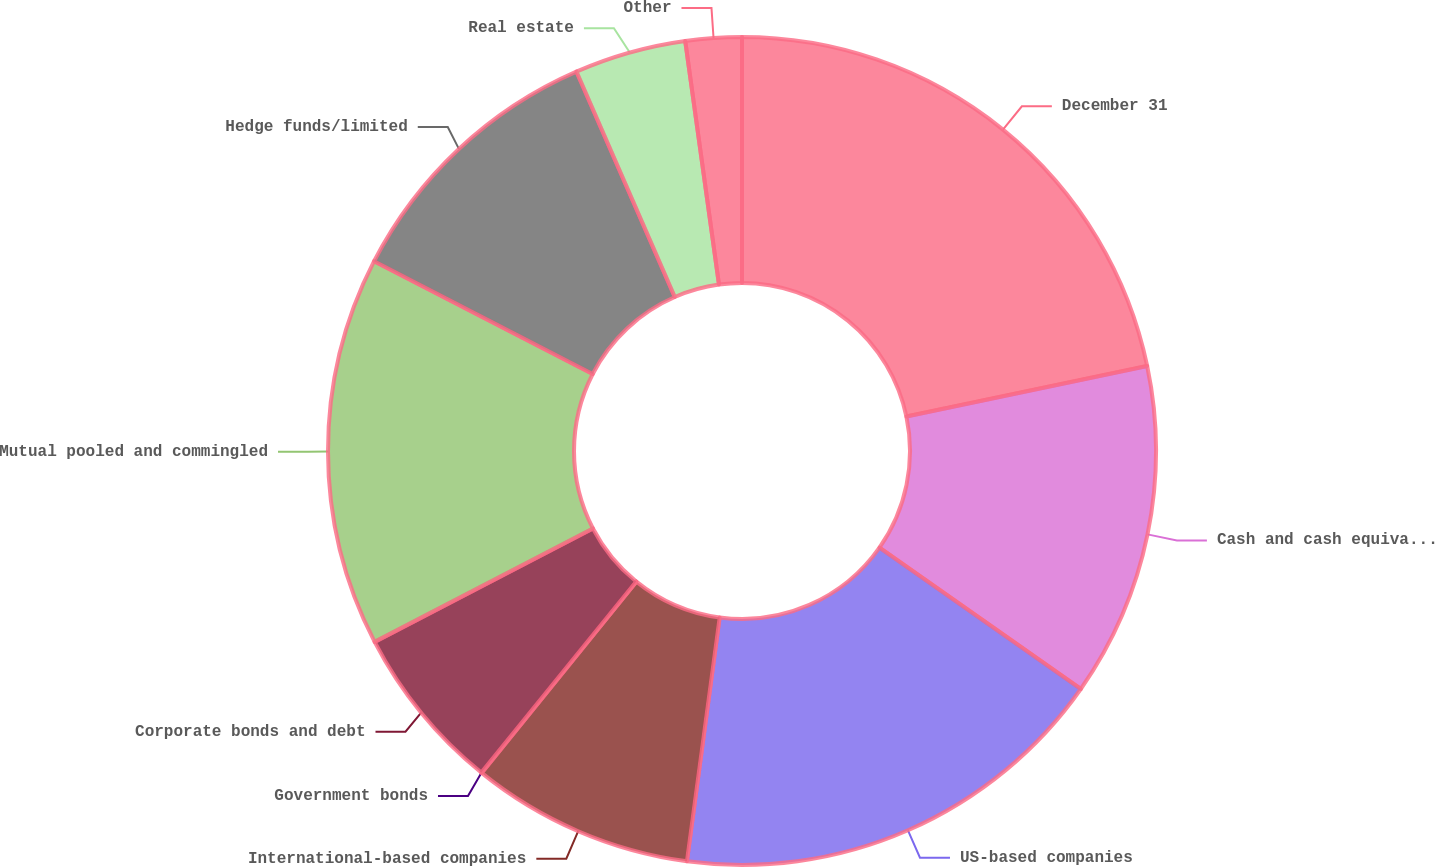Convert chart. <chart><loc_0><loc_0><loc_500><loc_500><pie_chart><fcel>December 31<fcel>Cash and cash equivalents<fcel>US-based companies<fcel>International-based companies<fcel>Government bonds<fcel>Corporate bonds and debt<fcel>Mutual pooled and commingled<fcel>Hedge funds/limited<fcel>Real estate<fcel>Other<nl><fcel>21.71%<fcel>13.04%<fcel>17.38%<fcel>8.7%<fcel>0.02%<fcel>6.53%<fcel>15.21%<fcel>10.87%<fcel>4.36%<fcel>2.19%<nl></chart> 